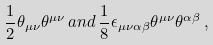Convert formula to latex. <formula><loc_0><loc_0><loc_500><loc_500>\frac { 1 } { 2 } \theta _ { \mu \nu } \theta ^ { \mu \nu } \, a n d \, \frac { 1 } { 8 } \epsilon _ { \mu \nu \alpha \beta } \theta ^ { \mu \nu } \theta ^ { \alpha \beta } \, ,</formula> 